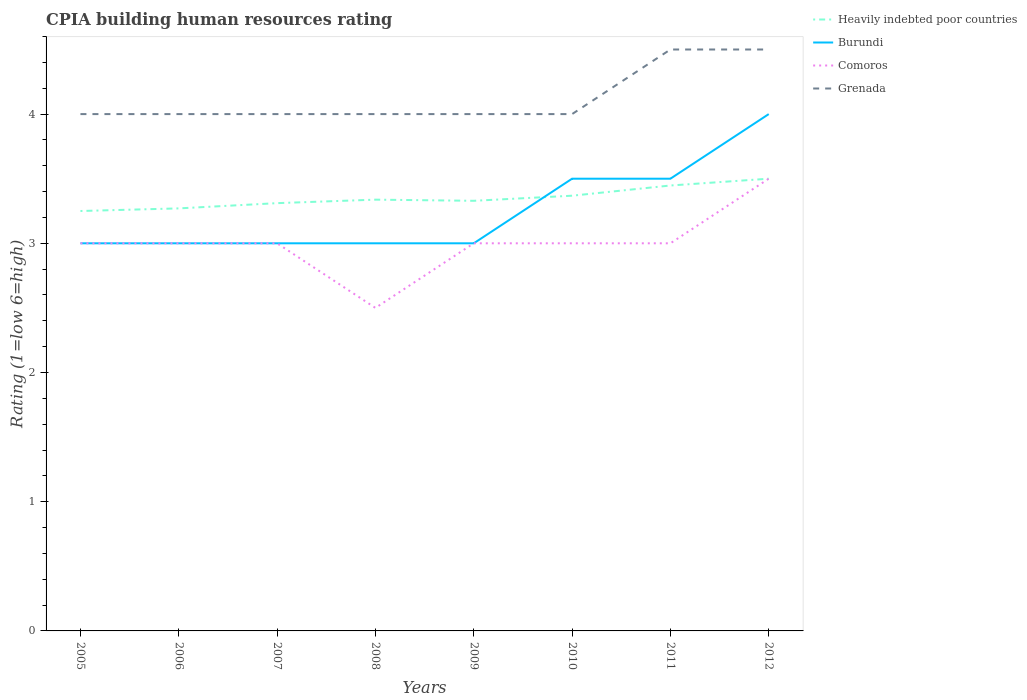How many different coloured lines are there?
Offer a terse response. 4. Does the line corresponding to Heavily indebted poor countries intersect with the line corresponding to Comoros?
Give a very brief answer. Yes. Across all years, what is the maximum CPIA rating in Comoros?
Your answer should be compact. 2.5. What is the total CPIA rating in Grenada in the graph?
Give a very brief answer. 0. What is the difference between the highest and the lowest CPIA rating in Burundi?
Keep it short and to the point. 3. Is the CPIA rating in Grenada strictly greater than the CPIA rating in Heavily indebted poor countries over the years?
Make the answer very short. No. How many lines are there?
Make the answer very short. 4. How many years are there in the graph?
Your answer should be very brief. 8. What is the difference between two consecutive major ticks on the Y-axis?
Offer a very short reply. 1. Are the values on the major ticks of Y-axis written in scientific E-notation?
Your answer should be very brief. No. Does the graph contain grids?
Keep it short and to the point. No. Where does the legend appear in the graph?
Give a very brief answer. Top right. How many legend labels are there?
Your answer should be compact. 4. What is the title of the graph?
Keep it short and to the point. CPIA building human resources rating. What is the label or title of the Y-axis?
Offer a very short reply. Rating (1=low 6=high). What is the Rating (1=low 6=high) of Burundi in 2005?
Provide a short and direct response. 3. What is the Rating (1=low 6=high) of Comoros in 2005?
Ensure brevity in your answer.  3. What is the Rating (1=low 6=high) in Grenada in 2005?
Offer a very short reply. 4. What is the Rating (1=low 6=high) in Heavily indebted poor countries in 2006?
Offer a terse response. 3.27. What is the Rating (1=low 6=high) of Burundi in 2006?
Ensure brevity in your answer.  3. What is the Rating (1=low 6=high) of Comoros in 2006?
Ensure brevity in your answer.  3. What is the Rating (1=low 6=high) in Heavily indebted poor countries in 2007?
Offer a terse response. 3.31. What is the Rating (1=low 6=high) of Burundi in 2007?
Offer a terse response. 3. What is the Rating (1=low 6=high) in Grenada in 2007?
Your response must be concise. 4. What is the Rating (1=low 6=high) in Heavily indebted poor countries in 2008?
Make the answer very short. 3.34. What is the Rating (1=low 6=high) of Heavily indebted poor countries in 2009?
Keep it short and to the point. 3.33. What is the Rating (1=low 6=high) of Comoros in 2009?
Keep it short and to the point. 3. What is the Rating (1=low 6=high) of Heavily indebted poor countries in 2010?
Offer a very short reply. 3.37. What is the Rating (1=low 6=high) in Burundi in 2010?
Your answer should be compact. 3.5. What is the Rating (1=low 6=high) in Comoros in 2010?
Your response must be concise. 3. What is the Rating (1=low 6=high) in Grenada in 2010?
Provide a short and direct response. 4. What is the Rating (1=low 6=high) in Heavily indebted poor countries in 2011?
Give a very brief answer. 3.45. What is the Rating (1=low 6=high) in Burundi in 2011?
Offer a very short reply. 3.5. What is the Rating (1=low 6=high) in Heavily indebted poor countries in 2012?
Your answer should be very brief. 3.5. What is the Rating (1=low 6=high) of Comoros in 2012?
Keep it short and to the point. 3.5. What is the Rating (1=low 6=high) of Grenada in 2012?
Give a very brief answer. 4.5. Across all years, what is the maximum Rating (1=low 6=high) in Grenada?
Ensure brevity in your answer.  4.5. Across all years, what is the minimum Rating (1=low 6=high) of Heavily indebted poor countries?
Make the answer very short. 3.25. Across all years, what is the minimum Rating (1=low 6=high) in Burundi?
Keep it short and to the point. 3. What is the total Rating (1=low 6=high) in Heavily indebted poor countries in the graph?
Provide a short and direct response. 26.81. What is the total Rating (1=low 6=high) of Burundi in the graph?
Keep it short and to the point. 26. What is the total Rating (1=low 6=high) of Comoros in the graph?
Offer a terse response. 24. What is the total Rating (1=low 6=high) in Grenada in the graph?
Your answer should be compact. 33. What is the difference between the Rating (1=low 6=high) of Heavily indebted poor countries in 2005 and that in 2006?
Your answer should be compact. -0.02. What is the difference between the Rating (1=low 6=high) in Burundi in 2005 and that in 2006?
Your answer should be compact. 0. What is the difference between the Rating (1=low 6=high) of Comoros in 2005 and that in 2006?
Offer a terse response. 0. What is the difference between the Rating (1=low 6=high) of Heavily indebted poor countries in 2005 and that in 2007?
Provide a succinct answer. -0.06. What is the difference between the Rating (1=low 6=high) in Comoros in 2005 and that in 2007?
Make the answer very short. 0. What is the difference between the Rating (1=low 6=high) in Grenada in 2005 and that in 2007?
Give a very brief answer. 0. What is the difference between the Rating (1=low 6=high) of Heavily indebted poor countries in 2005 and that in 2008?
Keep it short and to the point. -0.09. What is the difference between the Rating (1=low 6=high) of Burundi in 2005 and that in 2008?
Your response must be concise. 0. What is the difference between the Rating (1=low 6=high) of Comoros in 2005 and that in 2008?
Provide a short and direct response. 0.5. What is the difference between the Rating (1=low 6=high) in Heavily indebted poor countries in 2005 and that in 2009?
Offer a terse response. -0.08. What is the difference between the Rating (1=low 6=high) in Burundi in 2005 and that in 2009?
Offer a very short reply. 0. What is the difference between the Rating (1=low 6=high) of Grenada in 2005 and that in 2009?
Keep it short and to the point. 0. What is the difference between the Rating (1=low 6=high) in Heavily indebted poor countries in 2005 and that in 2010?
Keep it short and to the point. -0.12. What is the difference between the Rating (1=low 6=high) in Comoros in 2005 and that in 2010?
Provide a short and direct response. 0. What is the difference between the Rating (1=low 6=high) of Grenada in 2005 and that in 2010?
Provide a short and direct response. 0. What is the difference between the Rating (1=low 6=high) of Heavily indebted poor countries in 2005 and that in 2011?
Ensure brevity in your answer.  -0.2. What is the difference between the Rating (1=low 6=high) of Burundi in 2005 and that in 2011?
Offer a terse response. -0.5. What is the difference between the Rating (1=low 6=high) in Burundi in 2005 and that in 2012?
Make the answer very short. -1. What is the difference between the Rating (1=low 6=high) of Comoros in 2005 and that in 2012?
Provide a succinct answer. -0.5. What is the difference between the Rating (1=low 6=high) in Heavily indebted poor countries in 2006 and that in 2007?
Your response must be concise. -0.04. What is the difference between the Rating (1=low 6=high) of Burundi in 2006 and that in 2007?
Make the answer very short. 0. What is the difference between the Rating (1=low 6=high) in Heavily indebted poor countries in 2006 and that in 2008?
Provide a succinct answer. -0.07. What is the difference between the Rating (1=low 6=high) in Burundi in 2006 and that in 2008?
Your answer should be compact. 0. What is the difference between the Rating (1=low 6=high) of Grenada in 2006 and that in 2008?
Offer a terse response. 0. What is the difference between the Rating (1=low 6=high) in Heavily indebted poor countries in 2006 and that in 2009?
Keep it short and to the point. -0.06. What is the difference between the Rating (1=low 6=high) in Heavily indebted poor countries in 2006 and that in 2010?
Ensure brevity in your answer.  -0.1. What is the difference between the Rating (1=low 6=high) of Burundi in 2006 and that in 2010?
Provide a succinct answer. -0.5. What is the difference between the Rating (1=low 6=high) of Comoros in 2006 and that in 2010?
Your response must be concise. 0. What is the difference between the Rating (1=low 6=high) in Heavily indebted poor countries in 2006 and that in 2011?
Offer a terse response. -0.18. What is the difference between the Rating (1=low 6=high) of Burundi in 2006 and that in 2011?
Keep it short and to the point. -0.5. What is the difference between the Rating (1=low 6=high) of Grenada in 2006 and that in 2011?
Provide a short and direct response. -0.5. What is the difference between the Rating (1=low 6=high) of Heavily indebted poor countries in 2006 and that in 2012?
Offer a very short reply. -0.23. What is the difference between the Rating (1=low 6=high) in Comoros in 2006 and that in 2012?
Your answer should be very brief. -0.5. What is the difference between the Rating (1=low 6=high) in Grenada in 2006 and that in 2012?
Make the answer very short. -0.5. What is the difference between the Rating (1=low 6=high) of Heavily indebted poor countries in 2007 and that in 2008?
Offer a terse response. -0.03. What is the difference between the Rating (1=low 6=high) in Heavily indebted poor countries in 2007 and that in 2009?
Provide a short and direct response. -0.02. What is the difference between the Rating (1=low 6=high) in Burundi in 2007 and that in 2009?
Keep it short and to the point. 0. What is the difference between the Rating (1=low 6=high) in Heavily indebted poor countries in 2007 and that in 2010?
Offer a terse response. -0.06. What is the difference between the Rating (1=low 6=high) of Burundi in 2007 and that in 2010?
Provide a succinct answer. -0.5. What is the difference between the Rating (1=low 6=high) of Comoros in 2007 and that in 2010?
Keep it short and to the point. 0. What is the difference between the Rating (1=low 6=high) in Grenada in 2007 and that in 2010?
Offer a terse response. 0. What is the difference between the Rating (1=low 6=high) of Heavily indebted poor countries in 2007 and that in 2011?
Make the answer very short. -0.14. What is the difference between the Rating (1=low 6=high) in Grenada in 2007 and that in 2011?
Ensure brevity in your answer.  -0.5. What is the difference between the Rating (1=low 6=high) of Heavily indebted poor countries in 2007 and that in 2012?
Make the answer very short. -0.19. What is the difference between the Rating (1=low 6=high) in Burundi in 2007 and that in 2012?
Your answer should be compact. -1. What is the difference between the Rating (1=low 6=high) in Grenada in 2007 and that in 2012?
Offer a very short reply. -0.5. What is the difference between the Rating (1=low 6=high) in Heavily indebted poor countries in 2008 and that in 2009?
Make the answer very short. 0.01. What is the difference between the Rating (1=low 6=high) of Burundi in 2008 and that in 2009?
Offer a very short reply. 0. What is the difference between the Rating (1=low 6=high) of Comoros in 2008 and that in 2009?
Ensure brevity in your answer.  -0.5. What is the difference between the Rating (1=low 6=high) in Heavily indebted poor countries in 2008 and that in 2010?
Your answer should be very brief. -0.03. What is the difference between the Rating (1=low 6=high) in Burundi in 2008 and that in 2010?
Keep it short and to the point. -0.5. What is the difference between the Rating (1=low 6=high) of Comoros in 2008 and that in 2010?
Keep it short and to the point. -0.5. What is the difference between the Rating (1=low 6=high) in Grenada in 2008 and that in 2010?
Keep it short and to the point. 0. What is the difference between the Rating (1=low 6=high) of Heavily indebted poor countries in 2008 and that in 2011?
Give a very brief answer. -0.11. What is the difference between the Rating (1=low 6=high) in Heavily indebted poor countries in 2008 and that in 2012?
Ensure brevity in your answer.  -0.16. What is the difference between the Rating (1=low 6=high) of Comoros in 2008 and that in 2012?
Offer a very short reply. -1. What is the difference between the Rating (1=low 6=high) of Heavily indebted poor countries in 2009 and that in 2010?
Provide a succinct answer. -0.04. What is the difference between the Rating (1=low 6=high) in Comoros in 2009 and that in 2010?
Your answer should be compact. 0. What is the difference between the Rating (1=low 6=high) of Grenada in 2009 and that in 2010?
Ensure brevity in your answer.  0. What is the difference between the Rating (1=low 6=high) in Heavily indebted poor countries in 2009 and that in 2011?
Your answer should be compact. -0.12. What is the difference between the Rating (1=low 6=high) of Burundi in 2009 and that in 2011?
Your answer should be very brief. -0.5. What is the difference between the Rating (1=low 6=high) in Heavily indebted poor countries in 2009 and that in 2012?
Provide a short and direct response. -0.17. What is the difference between the Rating (1=low 6=high) in Heavily indebted poor countries in 2010 and that in 2011?
Ensure brevity in your answer.  -0.08. What is the difference between the Rating (1=low 6=high) in Comoros in 2010 and that in 2011?
Ensure brevity in your answer.  0. What is the difference between the Rating (1=low 6=high) in Grenada in 2010 and that in 2011?
Provide a short and direct response. -0.5. What is the difference between the Rating (1=low 6=high) in Heavily indebted poor countries in 2010 and that in 2012?
Give a very brief answer. -0.13. What is the difference between the Rating (1=low 6=high) of Heavily indebted poor countries in 2011 and that in 2012?
Keep it short and to the point. -0.05. What is the difference between the Rating (1=low 6=high) in Comoros in 2011 and that in 2012?
Provide a short and direct response. -0.5. What is the difference between the Rating (1=low 6=high) of Grenada in 2011 and that in 2012?
Provide a succinct answer. 0. What is the difference between the Rating (1=low 6=high) of Heavily indebted poor countries in 2005 and the Rating (1=low 6=high) of Comoros in 2006?
Keep it short and to the point. 0.25. What is the difference between the Rating (1=low 6=high) of Heavily indebted poor countries in 2005 and the Rating (1=low 6=high) of Grenada in 2006?
Give a very brief answer. -0.75. What is the difference between the Rating (1=low 6=high) of Burundi in 2005 and the Rating (1=low 6=high) of Comoros in 2006?
Offer a very short reply. 0. What is the difference between the Rating (1=low 6=high) in Heavily indebted poor countries in 2005 and the Rating (1=low 6=high) in Burundi in 2007?
Provide a succinct answer. 0.25. What is the difference between the Rating (1=low 6=high) of Heavily indebted poor countries in 2005 and the Rating (1=low 6=high) of Grenada in 2007?
Your response must be concise. -0.75. What is the difference between the Rating (1=low 6=high) of Comoros in 2005 and the Rating (1=low 6=high) of Grenada in 2007?
Make the answer very short. -1. What is the difference between the Rating (1=low 6=high) of Heavily indebted poor countries in 2005 and the Rating (1=low 6=high) of Comoros in 2008?
Your answer should be very brief. 0.75. What is the difference between the Rating (1=low 6=high) in Heavily indebted poor countries in 2005 and the Rating (1=low 6=high) in Grenada in 2008?
Provide a succinct answer. -0.75. What is the difference between the Rating (1=low 6=high) of Burundi in 2005 and the Rating (1=low 6=high) of Grenada in 2008?
Offer a terse response. -1. What is the difference between the Rating (1=low 6=high) in Comoros in 2005 and the Rating (1=low 6=high) in Grenada in 2008?
Provide a succinct answer. -1. What is the difference between the Rating (1=low 6=high) of Heavily indebted poor countries in 2005 and the Rating (1=low 6=high) of Comoros in 2009?
Offer a very short reply. 0.25. What is the difference between the Rating (1=low 6=high) in Heavily indebted poor countries in 2005 and the Rating (1=low 6=high) in Grenada in 2009?
Give a very brief answer. -0.75. What is the difference between the Rating (1=low 6=high) in Burundi in 2005 and the Rating (1=low 6=high) in Grenada in 2009?
Provide a short and direct response. -1. What is the difference between the Rating (1=low 6=high) in Comoros in 2005 and the Rating (1=low 6=high) in Grenada in 2009?
Your response must be concise. -1. What is the difference between the Rating (1=low 6=high) in Heavily indebted poor countries in 2005 and the Rating (1=low 6=high) in Comoros in 2010?
Provide a succinct answer. 0.25. What is the difference between the Rating (1=low 6=high) of Heavily indebted poor countries in 2005 and the Rating (1=low 6=high) of Grenada in 2010?
Your answer should be compact. -0.75. What is the difference between the Rating (1=low 6=high) of Burundi in 2005 and the Rating (1=low 6=high) of Comoros in 2010?
Ensure brevity in your answer.  0. What is the difference between the Rating (1=low 6=high) in Burundi in 2005 and the Rating (1=low 6=high) in Grenada in 2010?
Your answer should be very brief. -1. What is the difference between the Rating (1=low 6=high) in Comoros in 2005 and the Rating (1=low 6=high) in Grenada in 2010?
Give a very brief answer. -1. What is the difference between the Rating (1=low 6=high) of Heavily indebted poor countries in 2005 and the Rating (1=low 6=high) of Comoros in 2011?
Provide a succinct answer. 0.25. What is the difference between the Rating (1=low 6=high) of Heavily indebted poor countries in 2005 and the Rating (1=low 6=high) of Grenada in 2011?
Your answer should be compact. -1.25. What is the difference between the Rating (1=low 6=high) of Burundi in 2005 and the Rating (1=low 6=high) of Grenada in 2011?
Give a very brief answer. -1.5. What is the difference between the Rating (1=low 6=high) in Heavily indebted poor countries in 2005 and the Rating (1=low 6=high) in Burundi in 2012?
Provide a succinct answer. -0.75. What is the difference between the Rating (1=low 6=high) of Heavily indebted poor countries in 2005 and the Rating (1=low 6=high) of Comoros in 2012?
Your response must be concise. -0.25. What is the difference between the Rating (1=low 6=high) of Heavily indebted poor countries in 2005 and the Rating (1=low 6=high) of Grenada in 2012?
Provide a succinct answer. -1.25. What is the difference between the Rating (1=low 6=high) of Comoros in 2005 and the Rating (1=low 6=high) of Grenada in 2012?
Offer a terse response. -1.5. What is the difference between the Rating (1=low 6=high) in Heavily indebted poor countries in 2006 and the Rating (1=low 6=high) in Burundi in 2007?
Provide a short and direct response. 0.27. What is the difference between the Rating (1=low 6=high) of Heavily indebted poor countries in 2006 and the Rating (1=low 6=high) of Comoros in 2007?
Ensure brevity in your answer.  0.27. What is the difference between the Rating (1=low 6=high) of Heavily indebted poor countries in 2006 and the Rating (1=low 6=high) of Grenada in 2007?
Provide a short and direct response. -0.73. What is the difference between the Rating (1=low 6=high) in Burundi in 2006 and the Rating (1=low 6=high) in Comoros in 2007?
Provide a succinct answer. 0. What is the difference between the Rating (1=low 6=high) of Burundi in 2006 and the Rating (1=low 6=high) of Grenada in 2007?
Keep it short and to the point. -1. What is the difference between the Rating (1=low 6=high) of Comoros in 2006 and the Rating (1=low 6=high) of Grenada in 2007?
Offer a very short reply. -1. What is the difference between the Rating (1=low 6=high) in Heavily indebted poor countries in 2006 and the Rating (1=low 6=high) in Burundi in 2008?
Offer a very short reply. 0.27. What is the difference between the Rating (1=low 6=high) in Heavily indebted poor countries in 2006 and the Rating (1=low 6=high) in Comoros in 2008?
Provide a succinct answer. 0.77. What is the difference between the Rating (1=low 6=high) in Heavily indebted poor countries in 2006 and the Rating (1=low 6=high) in Grenada in 2008?
Provide a succinct answer. -0.73. What is the difference between the Rating (1=low 6=high) of Burundi in 2006 and the Rating (1=low 6=high) of Comoros in 2008?
Offer a very short reply. 0.5. What is the difference between the Rating (1=low 6=high) in Comoros in 2006 and the Rating (1=low 6=high) in Grenada in 2008?
Your answer should be very brief. -1. What is the difference between the Rating (1=low 6=high) of Heavily indebted poor countries in 2006 and the Rating (1=low 6=high) of Burundi in 2009?
Offer a terse response. 0.27. What is the difference between the Rating (1=low 6=high) in Heavily indebted poor countries in 2006 and the Rating (1=low 6=high) in Comoros in 2009?
Keep it short and to the point. 0.27. What is the difference between the Rating (1=low 6=high) of Heavily indebted poor countries in 2006 and the Rating (1=low 6=high) of Grenada in 2009?
Your response must be concise. -0.73. What is the difference between the Rating (1=low 6=high) of Comoros in 2006 and the Rating (1=low 6=high) of Grenada in 2009?
Provide a succinct answer. -1. What is the difference between the Rating (1=low 6=high) of Heavily indebted poor countries in 2006 and the Rating (1=low 6=high) of Burundi in 2010?
Offer a very short reply. -0.23. What is the difference between the Rating (1=low 6=high) in Heavily indebted poor countries in 2006 and the Rating (1=low 6=high) in Comoros in 2010?
Offer a very short reply. 0.27. What is the difference between the Rating (1=low 6=high) in Heavily indebted poor countries in 2006 and the Rating (1=low 6=high) in Grenada in 2010?
Your response must be concise. -0.73. What is the difference between the Rating (1=low 6=high) of Burundi in 2006 and the Rating (1=low 6=high) of Comoros in 2010?
Give a very brief answer. 0. What is the difference between the Rating (1=low 6=high) in Burundi in 2006 and the Rating (1=low 6=high) in Grenada in 2010?
Make the answer very short. -1. What is the difference between the Rating (1=low 6=high) of Heavily indebted poor countries in 2006 and the Rating (1=low 6=high) of Burundi in 2011?
Keep it short and to the point. -0.23. What is the difference between the Rating (1=low 6=high) of Heavily indebted poor countries in 2006 and the Rating (1=low 6=high) of Comoros in 2011?
Provide a short and direct response. 0.27. What is the difference between the Rating (1=low 6=high) of Heavily indebted poor countries in 2006 and the Rating (1=low 6=high) of Grenada in 2011?
Offer a terse response. -1.23. What is the difference between the Rating (1=low 6=high) in Burundi in 2006 and the Rating (1=low 6=high) in Comoros in 2011?
Your answer should be very brief. 0. What is the difference between the Rating (1=low 6=high) of Heavily indebted poor countries in 2006 and the Rating (1=low 6=high) of Burundi in 2012?
Make the answer very short. -0.73. What is the difference between the Rating (1=low 6=high) in Heavily indebted poor countries in 2006 and the Rating (1=low 6=high) in Comoros in 2012?
Provide a succinct answer. -0.23. What is the difference between the Rating (1=low 6=high) of Heavily indebted poor countries in 2006 and the Rating (1=low 6=high) of Grenada in 2012?
Offer a very short reply. -1.23. What is the difference between the Rating (1=low 6=high) in Burundi in 2006 and the Rating (1=low 6=high) in Comoros in 2012?
Your answer should be compact. -0.5. What is the difference between the Rating (1=low 6=high) in Burundi in 2006 and the Rating (1=low 6=high) in Grenada in 2012?
Keep it short and to the point. -1.5. What is the difference between the Rating (1=low 6=high) in Heavily indebted poor countries in 2007 and the Rating (1=low 6=high) in Burundi in 2008?
Your response must be concise. 0.31. What is the difference between the Rating (1=low 6=high) of Heavily indebted poor countries in 2007 and the Rating (1=low 6=high) of Comoros in 2008?
Ensure brevity in your answer.  0.81. What is the difference between the Rating (1=low 6=high) of Heavily indebted poor countries in 2007 and the Rating (1=low 6=high) of Grenada in 2008?
Your response must be concise. -0.69. What is the difference between the Rating (1=low 6=high) in Burundi in 2007 and the Rating (1=low 6=high) in Grenada in 2008?
Your answer should be very brief. -1. What is the difference between the Rating (1=low 6=high) of Comoros in 2007 and the Rating (1=low 6=high) of Grenada in 2008?
Ensure brevity in your answer.  -1. What is the difference between the Rating (1=low 6=high) in Heavily indebted poor countries in 2007 and the Rating (1=low 6=high) in Burundi in 2009?
Ensure brevity in your answer.  0.31. What is the difference between the Rating (1=low 6=high) of Heavily indebted poor countries in 2007 and the Rating (1=low 6=high) of Comoros in 2009?
Your answer should be compact. 0.31. What is the difference between the Rating (1=low 6=high) in Heavily indebted poor countries in 2007 and the Rating (1=low 6=high) in Grenada in 2009?
Your answer should be compact. -0.69. What is the difference between the Rating (1=low 6=high) in Heavily indebted poor countries in 2007 and the Rating (1=low 6=high) in Burundi in 2010?
Keep it short and to the point. -0.19. What is the difference between the Rating (1=low 6=high) of Heavily indebted poor countries in 2007 and the Rating (1=low 6=high) of Comoros in 2010?
Provide a short and direct response. 0.31. What is the difference between the Rating (1=low 6=high) of Heavily indebted poor countries in 2007 and the Rating (1=low 6=high) of Grenada in 2010?
Provide a short and direct response. -0.69. What is the difference between the Rating (1=low 6=high) of Burundi in 2007 and the Rating (1=low 6=high) of Comoros in 2010?
Your answer should be very brief. 0. What is the difference between the Rating (1=low 6=high) in Comoros in 2007 and the Rating (1=low 6=high) in Grenada in 2010?
Your answer should be compact. -1. What is the difference between the Rating (1=low 6=high) of Heavily indebted poor countries in 2007 and the Rating (1=low 6=high) of Burundi in 2011?
Provide a short and direct response. -0.19. What is the difference between the Rating (1=low 6=high) of Heavily indebted poor countries in 2007 and the Rating (1=low 6=high) of Comoros in 2011?
Your response must be concise. 0.31. What is the difference between the Rating (1=low 6=high) of Heavily indebted poor countries in 2007 and the Rating (1=low 6=high) of Grenada in 2011?
Ensure brevity in your answer.  -1.19. What is the difference between the Rating (1=low 6=high) of Burundi in 2007 and the Rating (1=low 6=high) of Comoros in 2011?
Offer a very short reply. 0. What is the difference between the Rating (1=low 6=high) of Comoros in 2007 and the Rating (1=low 6=high) of Grenada in 2011?
Give a very brief answer. -1.5. What is the difference between the Rating (1=low 6=high) of Heavily indebted poor countries in 2007 and the Rating (1=low 6=high) of Burundi in 2012?
Your answer should be compact. -0.69. What is the difference between the Rating (1=low 6=high) of Heavily indebted poor countries in 2007 and the Rating (1=low 6=high) of Comoros in 2012?
Provide a succinct answer. -0.19. What is the difference between the Rating (1=low 6=high) in Heavily indebted poor countries in 2007 and the Rating (1=low 6=high) in Grenada in 2012?
Your answer should be compact. -1.19. What is the difference between the Rating (1=low 6=high) in Burundi in 2007 and the Rating (1=low 6=high) in Grenada in 2012?
Make the answer very short. -1.5. What is the difference between the Rating (1=low 6=high) in Comoros in 2007 and the Rating (1=low 6=high) in Grenada in 2012?
Ensure brevity in your answer.  -1.5. What is the difference between the Rating (1=low 6=high) in Heavily indebted poor countries in 2008 and the Rating (1=low 6=high) in Burundi in 2009?
Ensure brevity in your answer.  0.34. What is the difference between the Rating (1=low 6=high) in Heavily indebted poor countries in 2008 and the Rating (1=low 6=high) in Comoros in 2009?
Ensure brevity in your answer.  0.34. What is the difference between the Rating (1=low 6=high) in Heavily indebted poor countries in 2008 and the Rating (1=low 6=high) in Grenada in 2009?
Offer a very short reply. -0.66. What is the difference between the Rating (1=low 6=high) of Burundi in 2008 and the Rating (1=low 6=high) of Grenada in 2009?
Ensure brevity in your answer.  -1. What is the difference between the Rating (1=low 6=high) in Heavily indebted poor countries in 2008 and the Rating (1=low 6=high) in Burundi in 2010?
Provide a succinct answer. -0.16. What is the difference between the Rating (1=low 6=high) of Heavily indebted poor countries in 2008 and the Rating (1=low 6=high) of Comoros in 2010?
Provide a succinct answer. 0.34. What is the difference between the Rating (1=low 6=high) in Heavily indebted poor countries in 2008 and the Rating (1=low 6=high) in Grenada in 2010?
Ensure brevity in your answer.  -0.66. What is the difference between the Rating (1=low 6=high) of Burundi in 2008 and the Rating (1=low 6=high) of Grenada in 2010?
Your answer should be very brief. -1. What is the difference between the Rating (1=low 6=high) in Heavily indebted poor countries in 2008 and the Rating (1=low 6=high) in Burundi in 2011?
Your answer should be compact. -0.16. What is the difference between the Rating (1=low 6=high) in Heavily indebted poor countries in 2008 and the Rating (1=low 6=high) in Comoros in 2011?
Your answer should be compact. 0.34. What is the difference between the Rating (1=low 6=high) of Heavily indebted poor countries in 2008 and the Rating (1=low 6=high) of Grenada in 2011?
Your answer should be compact. -1.16. What is the difference between the Rating (1=low 6=high) of Burundi in 2008 and the Rating (1=low 6=high) of Comoros in 2011?
Keep it short and to the point. 0. What is the difference between the Rating (1=low 6=high) in Heavily indebted poor countries in 2008 and the Rating (1=low 6=high) in Burundi in 2012?
Offer a very short reply. -0.66. What is the difference between the Rating (1=low 6=high) in Heavily indebted poor countries in 2008 and the Rating (1=low 6=high) in Comoros in 2012?
Your response must be concise. -0.16. What is the difference between the Rating (1=low 6=high) of Heavily indebted poor countries in 2008 and the Rating (1=low 6=high) of Grenada in 2012?
Your response must be concise. -1.16. What is the difference between the Rating (1=low 6=high) in Heavily indebted poor countries in 2009 and the Rating (1=low 6=high) in Burundi in 2010?
Provide a succinct answer. -0.17. What is the difference between the Rating (1=low 6=high) of Heavily indebted poor countries in 2009 and the Rating (1=low 6=high) of Comoros in 2010?
Offer a terse response. 0.33. What is the difference between the Rating (1=low 6=high) in Heavily indebted poor countries in 2009 and the Rating (1=low 6=high) in Grenada in 2010?
Your response must be concise. -0.67. What is the difference between the Rating (1=low 6=high) in Burundi in 2009 and the Rating (1=low 6=high) in Comoros in 2010?
Keep it short and to the point. 0. What is the difference between the Rating (1=low 6=high) of Burundi in 2009 and the Rating (1=low 6=high) of Grenada in 2010?
Your answer should be very brief. -1. What is the difference between the Rating (1=low 6=high) of Comoros in 2009 and the Rating (1=low 6=high) of Grenada in 2010?
Give a very brief answer. -1. What is the difference between the Rating (1=low 6=high) of Heavily indebted poor countries in 2009 and the Rating (1=low 6=high) of Burundi in 2011?
Your answer should be very brief. -0.17. What is the difference between the Rating (1=low 6=high) in Heavily indebted poor countries in 2009 and the Rating (1=low 6=high) in Comoros in 2011?
Keep it short and to the point. 0.33. What is the difference between the Rating (1=low 6=high) of Heavily indebted poor countries in 2009 and the Rating (1=low 6=high) of Grenada in 2011?
Give a very brief answer. -1.17. What is the difference between the Rating (1=low 6=high) of Burundi in 2009 and the Rating (1=low 6=high) of Comoros in 2011?
Offer a very short reply. 0. What is the difference between the Rating (1=low 6=high) of Burundi in 2009 and the Rating (1=low 6=high) of Grenada in 2011?
Your response must be concise. -1.5. What is the difference between the Rating (1=low 6=high) in Heavily indebted poor countries in 2009 and the Rating (1=low 6=high) in Burundi in 2012?
Offer a terse response. -0.67. What is the difference between the Rating (1=low 6=high) in Heavily indebted poor countries in 2009 and the Rating (1=low 6=high) in Comoros in 2012?
Give a very brief answer. -0.17. What is the difference between the Rating (1=low 6=high) in Heavily indebted poor countries in 2009 and the Rating (1=low 6=high) in Grenada in 2012?
Your response must be concise. -1.17. What is the difference between the Rating (1=low 6=high) of Burundi in 2009 and the Rating (1=low 6=high) of Comoros in 2012?
Your response must be concise. -0.5. What is the difference between the Rating (1=low 6=high) of Heavily indebted poor countries in 2010 and the Rating (1=low 6=high) of Burundi in 2011?
Offer a very short reply. -0.13. What is the difference between the Rating (1=low 6=high) of Heavily indebted poor countries in 2010 and the Rating (1=low 6=high) of Comoros in 2011?
Give a very brief answer. 0.37. What is the difference between the Rating (1=low 6=high) in Heavily indebted poor countries in 2010 and the Rating (1=low 6=high) in Grenada in 2011?
Keep it short and to the point. -1.13. What is the difference between the Rating (1=low 6=high) in Burundi in 2010 and the Rating (1=low 6=high) in Comoros in 2011?
Your answer should be compact. 0.5. What is the difference between the Rating (1=low 6=high) of Burundi in 2010 and the Rating (1=low 6=high) of Grenada in 2011?
Keep it short and to the point. -1. What is the difference between the Rating (1=low 6=high) in Comoros in 2010 and the Rating (1=low 6=high) in Grenada in 2011?
Provide a short and direct response. -1.5. What is the difference between the Rating (1=low 6=high) in Heavily indebted poor countries in 2010 and the Rating (1=low 6=high) in Burundi in 2012?
Offer a very short reply. -0.63. What is the difference between the Rating (1=low 6=high) in Heavily indebted poor countries in 2010 and the Rating (1=low 6=high) in Comoros in 2012?
Offer a very short reply. -0.13. What is the difference between the Rating (1=low 6=high) of Heavily indebted poor countries in 2010 and the Rating (1=low 6=high) of Grenada in 2012?
Offer a terse response. -1.13. What is the difference between the Rating (1=low 6=high) in Comoros in 2010 and the Rating (1=low 6=high) in Grenada in 2012?
Your response must be concise. -1.5. What is the difference between the Rating (1=low 6=high) in Heavily indebted poor countries in 2011 and the Rating (1=low 6=high) in Burundi in 2012?
Your answer should be very brief. -0.55. What is the difference between the Rating (1=low 6=high) in Heavily indebted poor countries in 2011 and the Rating (1=low 6=high) in Comoros in 2012?
Ensure brevity in your answer.  -0.05. What is the difference between the Rating (1=low 6=high) of Heavily indebted poor countries in 2011 and the Rating (1=low 6=high) of Grenada in 2012?
Offer a very short reply. -1.05. What is the difference between the Rating (1=low 6=high) of Burundi in 2011 and the Rating (1=low 6=high) of Grenada in 2012?
Your answer should be compact. -1. What is the difference between the Rating (1=low 6=high) in Comoros in 2011 and the Rating (1=low 6=high) in Grenada in 2012?
Provide a succinct answer. -1.5. What is the average Rating (1=low 6=high) of Heavily indebted poor countries per year?
Your answer should be compact. 3.35. What is the average Rating (1=low 6=high) of Burundi per year?
Your answer should be very brief. 3.25. What is the average Rating (1=low 6=high) in Grenada per year?
Provide a succinct answer. 4.12. In the year 2005, what is the difference between the Rating (1=low 6=high) of Heavily indebted poor countries and Rating (1=low 6=high) of Grenada?
Give a very brief answer. -0.75. In the year 2005, what is the difference between the Rating (1=low 6=high) of Burundi and Rating (1=low 6=high) of Comoros?
Make the answer very short. 0. In the year 2006, what is the difference between the Rating (1=low 6=high) in Heavily indebted poor countries and Rating (1=low 6=high) in Burundi?
Provide a short and direct response. 0.27. In the year 2006, what is the difference between the Rating (1=low 6=high) in Heavily indebted poor countries and Rating (1=low 6=high) in Comoros?
Your answer should be very brief. 0.27. In the year 2006, what is the difference between the Rating (1=low 6=high) of Heavily indebted poor countries and Rating (1=low 6=high) of Grenada?
Ensure brevity in your answer.  -0.73. In the year 2006, what is the difference between the Rating (1=low 6=high) in Burundi and Rating (1=low 6=high) in Grenada?
Your answer should be compact. -1. In the year 2006, what is the difference between the Rating (1=low 6=high) of Comoros and Rating (1=low 6=high) of Grenada?
Your answer should be very brief. -1. In the year 2007, what is the difference between the Rating (1=low 6=high) of Heavily indebted poor countries and Rating (1=low 6=high) of Burundi?
Offer a very short reply. 0.31. In the year 2007, what is the difference between the Rating (1=low 6=high) of Heavily indebted poor countries and Rating (1=low 6=high) of Comoros?
Your answer should be very brief. 0.31. In the year 2007, what is the difference between the Rating (1=low 6=high) in Heavily indebted poor countries and Rating (1=low 6=high) in Grenada?
Ensure brevity in your answer.  -0.69. In the year 2007, what is the difference between the Rating (1=low 6=high) of Burundi and Rating (1=low 6=high) of Comoros?
Give a very brief answer. 0. In the year 2007, what is the difference between the Rating (1=low 6=high) of Comoros and Rating (1=low 6=high) of Grenada?
Give a very brief answer. -1. In the year 2008, what is the difference between the Rating (1=low 6=high) of Heavily indebted poor countries and Rating (1=low 6=high) of Burundi?
Your answer should be very brief. 0.34. In the year 2008, what is the difference between the Rating (1=low 6=high) in Heavily indebted poor countries and Rating (1=low 6=high) in Comoros?
Ensure brevity in your answer.  0.84. In the year 2008, what is the difference between the Rating (1=low 6=high) of Heavily indebted poor countries and Rating (1=low 6=high) of Grenada?
Give a very brief answer. -0.66. In the year 2008, what is the difference between the Rating (1=low 6=high) of Burundi and Rating (1=low 6=high) of Grenada?
Make the answer very short. -1. In the year 2008, what is the difference between the Rating (1=low 6=high) of Comoros and Rating (1=low 6=high) of Grenada?
Offer a very short reply. -1.5. In the year 2009, what is the difference between the Rating (1=low 6=high) of Heavily indebted poor countries and Rating (1=low 6=high) of Burundi?
Make the answer very short. 0.33. In the year 2009, what is the difference between the Rating (1=low 6=high) of Heavily indebted poor countries and Rating (1=low 6=high) of Comoros?
Offer a terse response. 0.33. In the year 2009, what is the difference between the Rating (1=low 6=high) of Heavily indebted poor countries and Rating (1=low 6=high) of Grenada?
Keep it short and to the point. -0.67. In the year 2009, what is the difference between the Rating (1=low 6=high) in Burundi and Rating (1=low 6=high) in Comoros?
Provide a short and direct response. 0. In the year 2010, what is the difference between the Rating (1=low 6=high) in Heavily indebted poor countries and Rating (1=low 6=high) in Burundi?
Offer a terse response. -0.13. In the year 2010, what is the difference between the Rating (1=low 6=high) of Heavily indebted poor countries and Rating (1=low 6=high) of Comoros?
Give a very brief answer. 0.37. In the year 2010, what is the difference between the Rating (1=low 6=high) of Heavily indebted poor countries and Rating (1=low 6=high) of Grenada?
Provide a succinct answer. -0.63. In the year 2010, what is the difference between the Rating (1=low 6=high) of Burundi and Rating (1=low 6=high) of Comoros?
Provide a succinct answer. 0.5. In the year 2010, what is the difference between the Rating (1=low 6=high) of Burundi and Rating (1=low 6=high) of Grenada?
Offer a terse response. -0.5. In the year 2011, what is the difference between the Rating (1=low 6=high) in Heavily indebted poor countries and Rating (1=low 6=high) in Burundi?
Your answer should be very brief. -0.05. In the year 2011, what is the difference between the Rating (1=low 6=high) in Heavily indebted poor countries and Rating (1=low 6=high) in Comoros?
Make the answer very short. 0.45. In the year 2011, what is the difference between the Rating (1=low 6=high) of Heavily indebted poor countries and Rating (1=low 6=high) of Grenada?
Offer a terse response. -1.05. In the year 2011, what is the difference between the Rating (1=low 6=high) in Burundi and Rating (1=low 6=high) in Grenada?
Offer a very short reply. -1. In the year 2011, what is the difference between the Rating (1=low 6=high) of Comoros and Rating (1=low 6=high) of Grenada?
Ensure brevity in your answer.  -1.5. In the year 2012, what is the difference between the Rating (1=low 6=high) in Heavily indebted poor countries and Rating (1=low 6=high) in Grenada?
Your response must be concise. -1. In the year 2012, what is the difference between the Rating (1=low 6=high) of Burundi and Rating (1=low 6=high) of Grenada?
Make the answer very short. -0.5. In the year 2012, what is the difference between the Rating (1=low 6=high) in Comoros and Rating (1=low 6=high) in Grenada?
Your answer should be very brief. -1. What is the ratio of the Rating (1=low 6=high) of Burundi in 2005 to that in 2006?
Your answer should be very brief. 1. What is the ratio of the Rating (1=low 6=high) in Comoros in 2005 to that in 2006?
Your answer should be very brief. 1. What is the ratio of the Rating (1=low 6=high) of Heavily indebted poor countries in 2005 to that in 2007?
Your response must be concise. 0.98. What is the ratio of the Rating (1=low 6=high) in Burundi in 2005 to that in 2007?
Keep it short and to the point. 1. What is the ratio of the Rating (1=low 6=high) of Comoros in 2005 to that in 2007?
Provide a short and direct response. 1. What is the ratio of the Rating (1=low 6=high) in Heavily indebted poor countries in 2005 to that in 2008?
Provide a succinct answer. 0.97. What is the ratio of the Rating (1=low 6=high) in Burundi in 2005 to that in 2008?
Keep it short and to the point. 1. What is the ratio of the Rating (1=low 6=high) of Heavily indebted poor countries in 2005 to that in 2009?
Your response must be concise. 0.98. What is the ratio of the Rating (1=low 6=high) of Comoros in 2005 to that in 2009?
Your answer should be very brief. 1. What is the ratio of the Rating (1=low 6=high) in Heavily indebted poor countries in 2005 to that in 2010?
Ensure brevity in your answer.  0.96. What is the ratio of the Rating (1=low 6=high) in Burundi in 2005 to that in 2010?
Provide a succinct answer. 0.86. What is the ratio of the Rating (1=low 6=high) in Heavily indebted poor countries in 2005 to that in 2011?
Make the answer very short. 0.94. What is the ratio of the Rating (1=low 6=high) in Grenada in 2005 to that in 2011?
Offer a very short reply. 0.89. What is the ratio of the Rating (1=low 6=high) of Comoros in 2005 to that in 2012?
Make the answer very short. 0.86. What is the ratio of the Rating (1=low 6=high) of Comoros in 2006 to that in 2007?
Provide a succinct answer. 1. What is the ratio of the Rating (1=low 6=high) in Heavily indebted poor countries in 2006 to that in 2008?
Make the answer very short. 0.98. What is the ratio of the Rating (1=low 6=high) in Comoros in 2006 to that in 2008?
Your answer should be very brief. 1.2. What is the ratio of the Rating (1=low 6=high) of Grenada in 2006 to that in 2008?
Your answer should be very brief. 1. What is the ratio of the Rating (1=low 6=high) of Heavily indebted poor countries in 2006 to that in 2009?
Offer a very short reply. 0.98. What is the ratio of the Rating (1=low 6=high) in Burundi in 2006 to that in 2009?
Provide a succinct answer. 1. What is the ratio of the Rating (1=low 6=high) of Comoros in 2006 to that in 2009?
Keep it short and to the point. 1. What is the ratio of the Rating (1=low 6=high) of Heavily indebted poor countries in 2006 to that in 2010?
Your answer should be compact. 0.97. What is the ratio of the Rating (1=low 6=high) in Burundi in 2006 to that in 2010?
Your answer should be very brief. 0.86. What is the ratio of the Rating (1=low 6=high) of Grenada in 2006 to that in 2010?
Ensure brevity in your answer.  1. What is the ratio of the Rating (1=low 6=high) in Heavily indebted poor countries in 2006 to that in 2011?
Make the answer very short. 0.95. What is the ratio of the Rating (1=low 6=high) of Heavily indebted poor countries in 2006 to that in 2012?
Provide a short and direct response. 0.93. What is the ratio of the Rating (1=low 6=high) in Burundi in 2006 to that in 2012?
Provide a succinct answer. 0.75. What is the ratio of the Rating (1=low 6=high) of Heavily indebted poor countries in 2007 to that in 2008?
Offer a terse response. 0.99. What is the ratio of the Rating (1=low 6=high) of Comoros in 2007 to that in 2008?
Make the answer very short. 1.2. What is the ratio of the Rating (1=low 6=high) in Grenada in 2007 to that in 2008?
Your response must be concise. 1. What is the ratio of the Rating (1=low 6=high) in Comoros in 2007 to that in 2009?
Offer a very short reply. 1. What is the ratio of the Rating (1=low 6=high) of Grenada in 2007 to that in 2009?
Your response must be concise. 1. What is the ratio of the Rating (1=low 6=high) of Heavily indebted poor countries in 2007 to that in 2010?
Your answer should be very brief. 0.98. What is the ratio of the Rating (1=low 6=high) of Comoros in 2007 to that in 2010?
Offer a terse response. 1. What is the ratio of the Rating (1=low 6=high) in Heavily indebted poor countries in 2007 to that in 2011?
Keep it short and to the point. 0.96. What is the ratio of the Rating (1=low 6=high) of Burundi in 2007 to that in 2011?
Your response must be concise. 0.86. What is the ratio of the Rating (1=low 6=high) in Heavily indebted poor countries in 2007 to that in 2012?
Give a very brief answer. 0.95. What is the ratio of the Rating (1=low 6=high) in Burundi in 2008 to that in 2009?
Make the answer very short. 1. What is the ratio of the Rating (1=low 6=high) in Heavily indebted poor countries in 2008 to that in 2010?
Your answer should be compact. 0.99. What is the ratio of the Rating (1=low 6=high) in Burundi in 2008 to that in 2010?
Offer a very short reply. 0.86. What is the ratio of the Rating (1=low 6=high) of Grenada in 2008 to that in 2010?
Ensure brevity in your answer.  1. What is the ratio of the Rating (1=low 6=high) in Heavily indebted poor countries in 2008 to that in 2011?
Provide a short and direct response. 0.97. What is the ratio of the Rating (1=low 6=high) in Grenada in 2008 to that in 2011?
Provide a succinct answer. 0.89. What is the ratio of the Rating (1=low 6=high) of Heavily indebted poor countries in 2008 to that in 2012?
Your answer should be compact. 0.95. What is the ratio of the Rating (1=low 6=high) of Heavily indebted poor countries in 2009 to that in 2010?
Provide a succinct answer. 0.99. What is the ratio of the Rating (1=low 6=high) in Grenada in 2009 to that in 2010?
Ensure brevity in your answer.  1. What is the ratio of the Rating (1=low 6=high) of Heavily indebted poor countries in 2009 to that in 2011?
Provide a succinct answer. 0.97. What is the ratio of the Rating (1=low 6=high) of Burundi in 2009 to that in 2011?
Keep it short and to the point. 0.86. What is the ratio of the Rating (1=low 6=high) in Comoros in 2009 to that in 2011?
Your answer should be very brief. 1. What is the ratio of the Rating (1=low 6=high) in Grenada in 2009 to that in 2011?
Your answer should be very brief. 0.89. What is the ratio of the Rating (1=low 6=high) in Heavily indebted poor countries in 2009 to that in 2012?
Your answer should be very brief. 0.95. What is the ratio of the Rating (1=low 6=high) of Burundi in 2009 to that in 2012?
Ensure brevity in your answer.  0.75. What is the ratio of the Rating (1=low 6=high) in Heavily indebted poor countries in 2010 to that in 2011?
Keep it short and to the point. 0.98. What is the ratio of the Rating (1=low 6=high) in Grenada in 2010 to that in 2011?
Your answer should be very brief. 0.89. What is the ratio of the Rating (1=low 6=high) in Heavily indebted poor countries in 2010 to that in 2012?
Keep it short and to the point. 0.96. What is the ratio of the Rating (1=low 6=high) in Burundi in 2010 to that in 2012?
Give a very brief answer. 0.88. What is the ratio of the Rating (1=low 6=high) of Grenada in 2010 to that in 2012?
Provide a succinct answer. 0.89. What is the ratio of the Rating (1=low 6=high) in Heavily indebted poor countries in 2011 to that in 2012?
Ensure brevity in your answer.  0.98. What is the ratio of the Rating (1=low 6=high) in Burundi in 2011 to that in 2012?
Your answer should be very brief. 0.88. What is the ratio of the Rating (1=low 6=high) in Grenada in 2011 to that in 2012?
Offer a terse response. 1. What is the difference between the highest and the second highest Rating (1=low 6=high) of Heavily indebted poor countries?
Keep it short and to the point. 0.05. What is the difference between the highest and the lowest Rating (1=low 6=high) of Heavily indebted poor countries?
Your answer should be compact. 0.25. What is the difference between the highest and the lowest Rating (1=low 6=high) of Burundi?
Your answer should be compact. 1. What is the difference between the highest and the lowest Rating (1=low 6=high) in Comoros?
Your response must be concise. 1. What is the difference between the highest and the lowest Rating (1=low 6=high) of Grenada?
Offer a terse response. 0.5. 